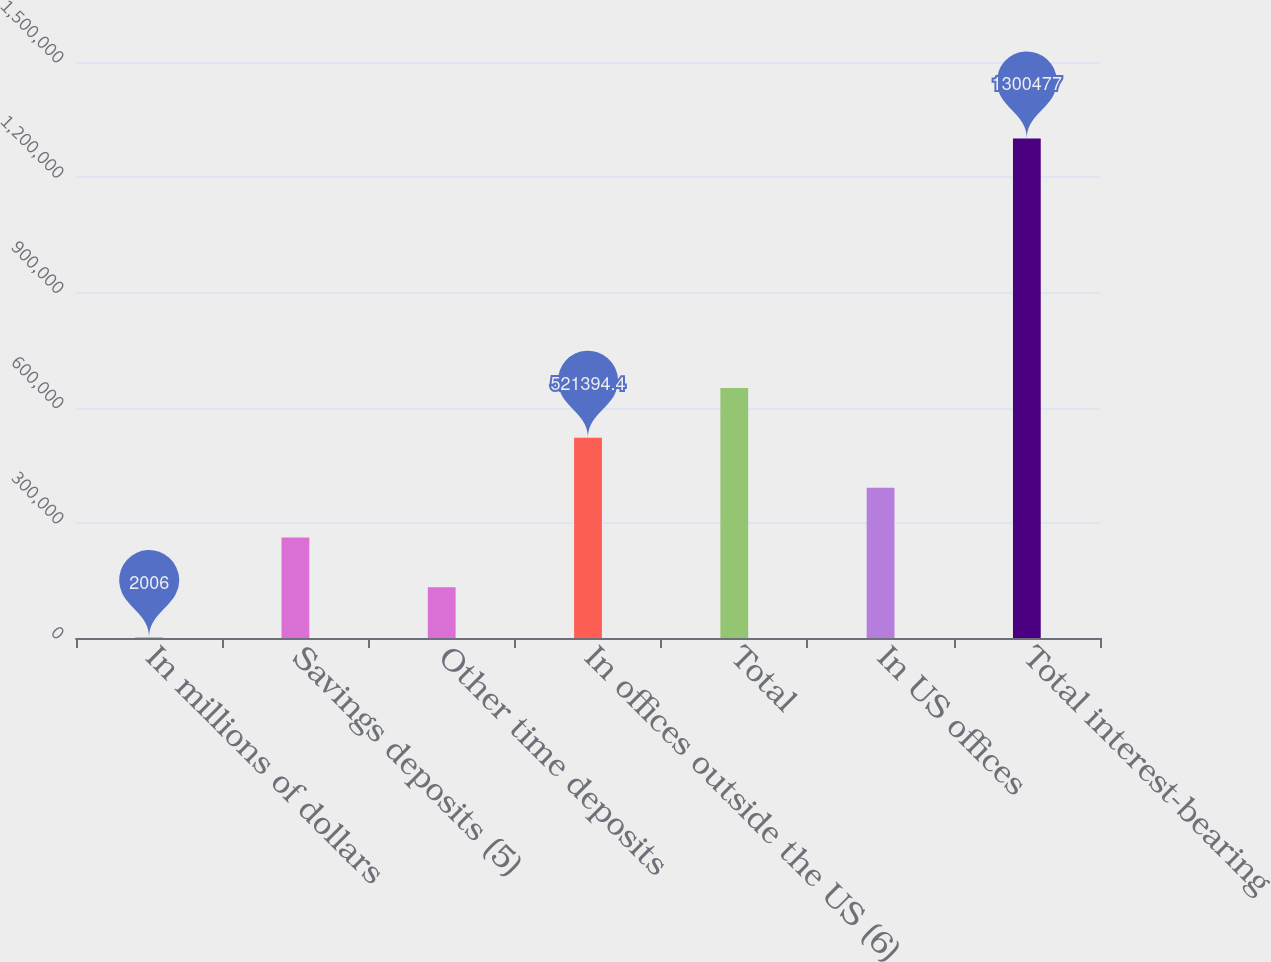Convert chart to OTSL. <chart><loc_0><loc_0><loc_500><loc_500><bar_chart><fcel>In millions of dollars<fcel>Savings deposits (5)<fcel>Other time deposits<fcel>In offices outside the US (6)<fcel>Total<fcel>In US offices<fcel>Total interest-bearing<nl><fcel>2006<fcel>261700<fcel>131853<fcel>521394<fcel>651242<fcel>391547<fcel>1.30048e+06<nl></chart> 